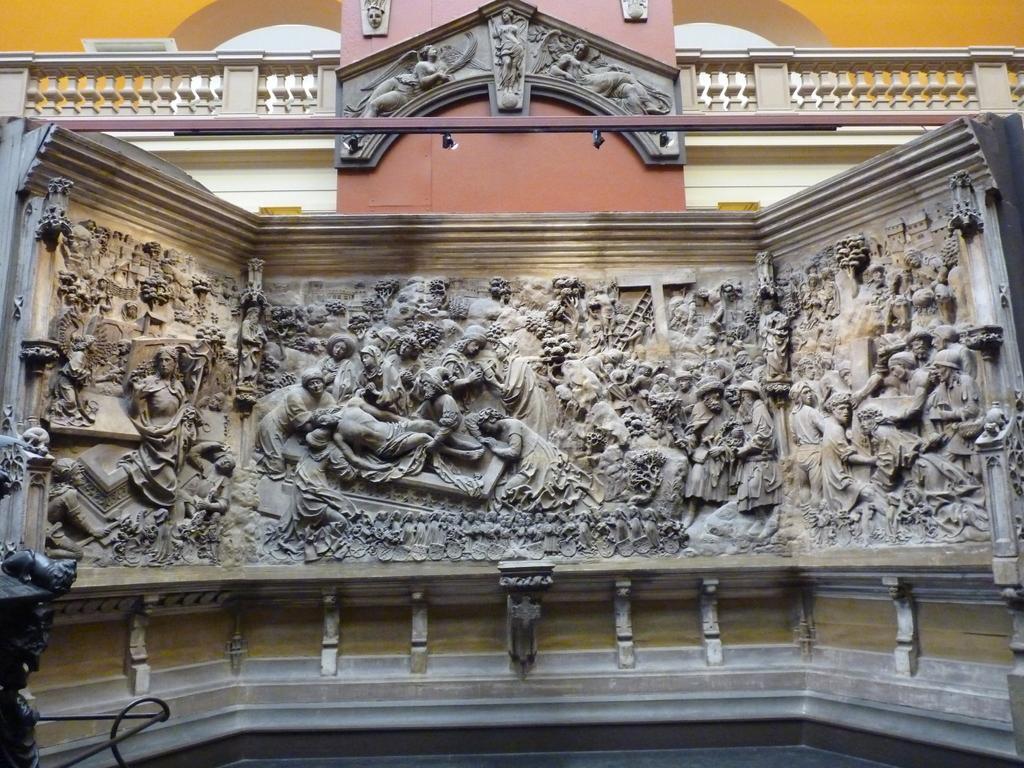Can you describe this image briefly? This picture is clicked outside. In the center we can see the wall of a building and we can see the wall carving of the persons on the wall of a building. In the background we can see the guard rail and the arch. 